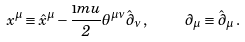Convert formula to latex. <formula><loc_0><loc_0><loc_500><loc_500>x ^ { \mu } \equiv \hat { x } ^ { \mu } - \frac { \i m u } { 2 } { \theta } ^ { \mu \nu } { \hat { \partial } } _ { \nu } \, , \quad \, { \partial } _ { \mu } \equiv \hat { \partial } _ { \mu } \, .</formula> 